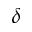Convert formula to latex. <formula><loc_0><loc_0><loc_500><loc_500>\delta</formula> 